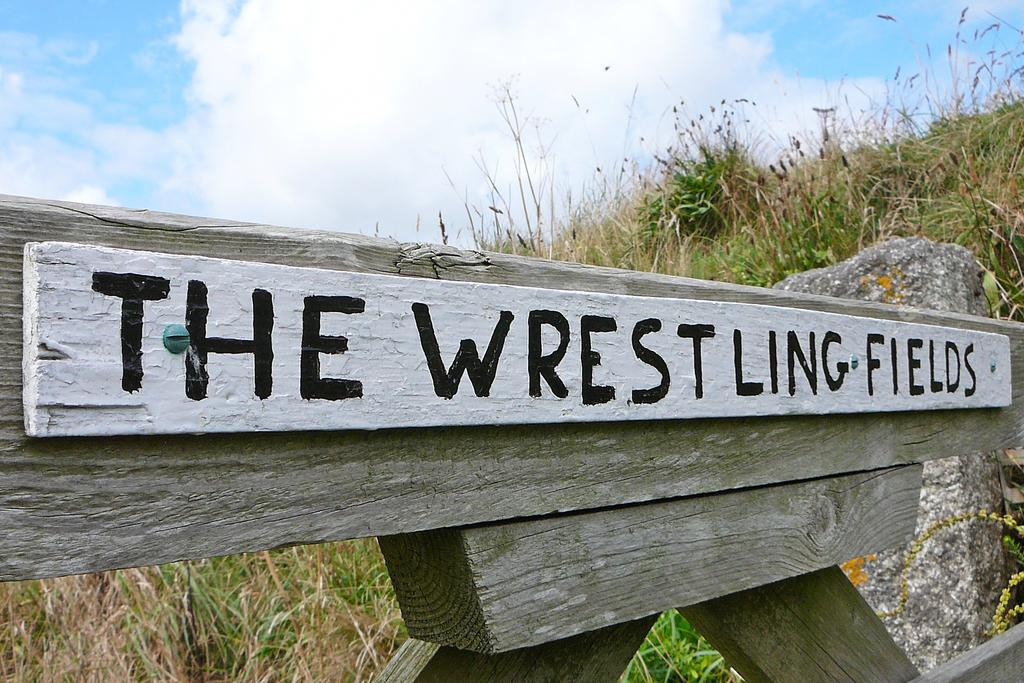What is the main wooden object in the image? There is a wooden board in the image. How is the wooden board connected to another wooden object? The wooden board is attached to another wooden object. What type of vegetation can be seen in the image? There is green grass and dry grass visible in the image. What is the color of the sky in the image? The sky is visible in the image, with a combination of white and blue colors. What type of riddle is being solved by the rock in the image? There is no riddle being solved by the rock in the image; it is simply a rock in the grass. 